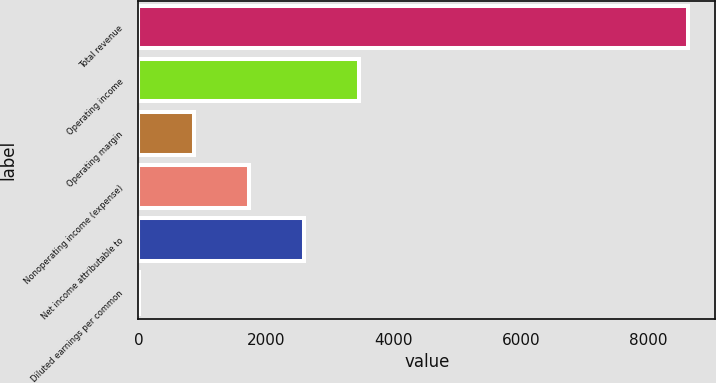Convert chart to OTSL. <chart><loc_0><loc_0><loc_500><loc_500><bar_chart><fcel>Total revenue<fcel>Operating income<fcel>Operating margin<fcel>Nonoperating income (expense)<fcel>Net income attributable to<fcel>Diluted earnings per common<nl><fcel>8612<fcel>3451.13<fcel>870.7<fcel>1730.85<fcel>2590.99<fcel>10.55<nl></chart> 